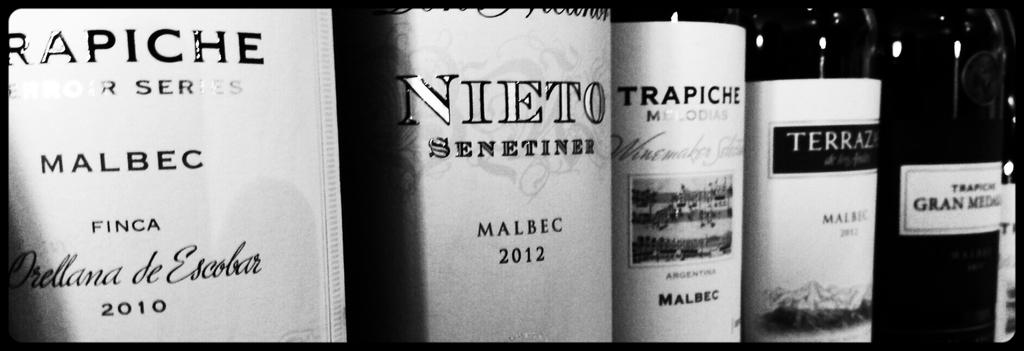What year is the left wine?
Ensure brevity in your answer.  2010. What year was nieto made?
Make the answer very short. 2012. 